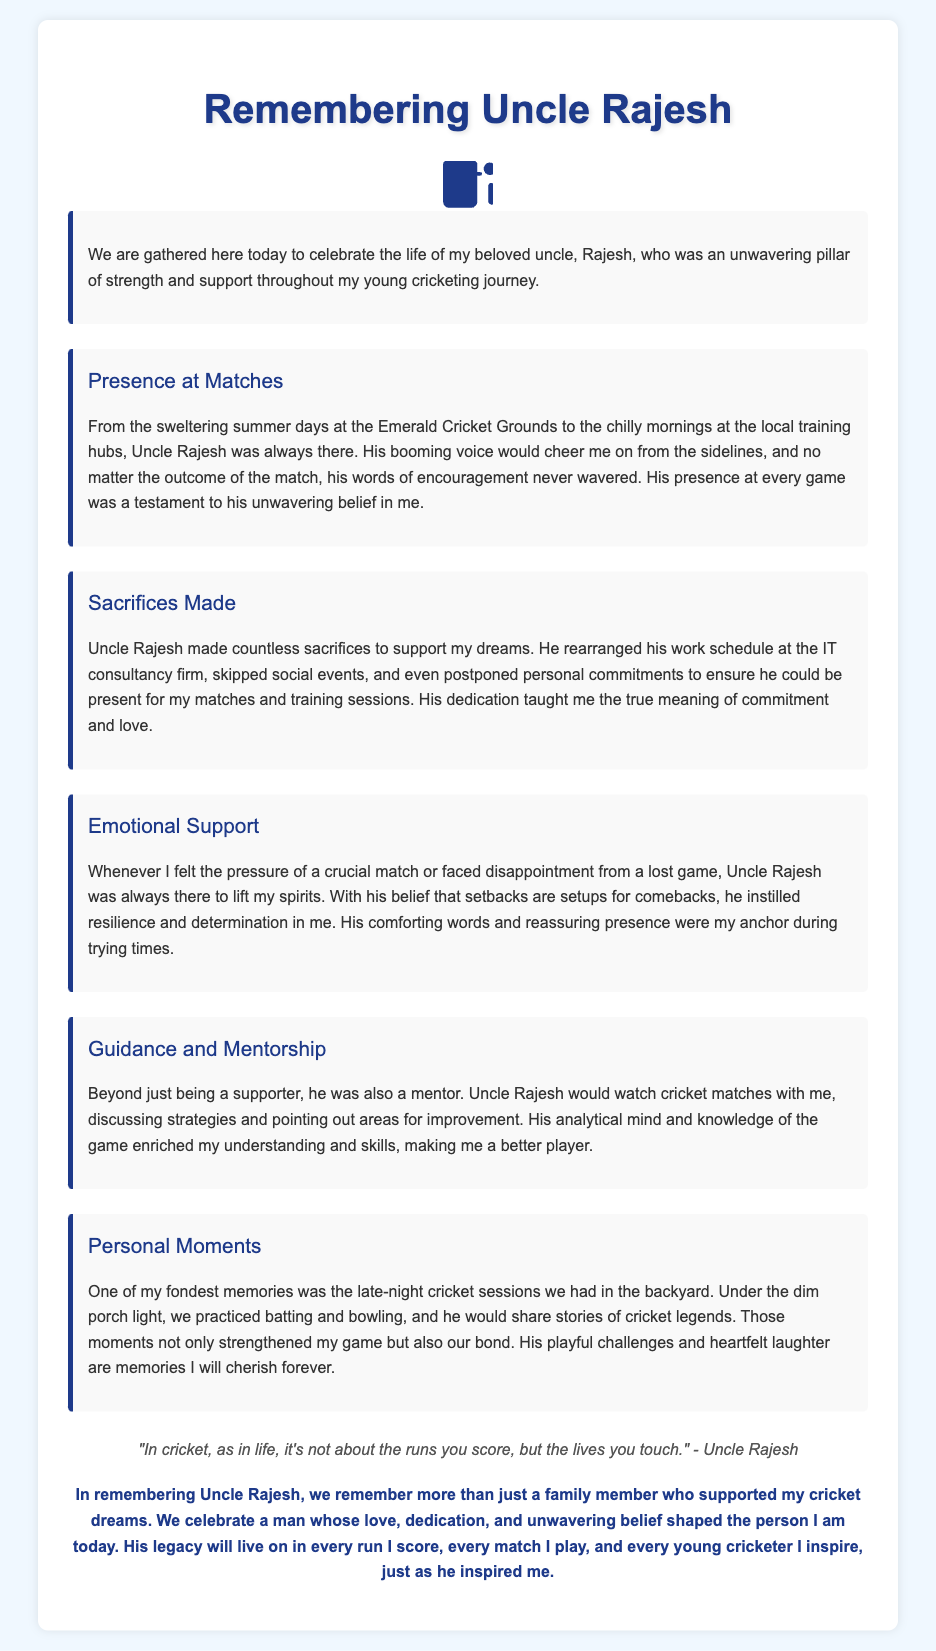What is the name of the person being remembered in the eulogy? The eulogy is dedicated to Uncle Rajesh, who is celebrated for his support and guidance in the speaker's cricketing journey.
Answer: Uncle Rajesh What did Uncle Rajesh rearrange to support the speaker’s dreams? Uncle Rajesh rearranged his work schedule at the IT consultancy firm to ensure he could attend matches and training sessions.
Answer: Work schedule Which metaphor did Uncle Rajesh use to instill resilience in the speaker? He expressed the idea that setbacks are setups for comebacks, encouraging a positive outlook despite difficulties faced in cricket.
Answer: Setbacks are setups for comebacks How did Uncle Rajesh engage in the speaker's cricket practice? He practiced batting and bowling with the speaker during late-night sessions and shared stories of cricket legends, fostering both skill development and bonding.
Answer: Late-night cricket sessions What does the speaker remember with fondness from his time with Uncle Rajesh? The speaker cherishes the moments practicing cricket in the backyard and the connection they built during those times.
Answer: Backyard cricket sessions What style is the document written in? The document is a eulogy, which typically encompasses remembrance and celebration of a person's life, shared during a memorial service.
Answer: Eulogy What does the quote in the eulogy highlight about cricket and life? The quote emphasizes that it's about the impact on others, rather than just personal success in the game.
Answer: Lives you touch Which qualities of Uncle Rajesh are highlighted in the eulogy? His love, dedication, mentorship, and unwavering belief in the speaker's potential are key qualities emphasized throughout the eulogy.
Answer: Love, dedication, mentorship 